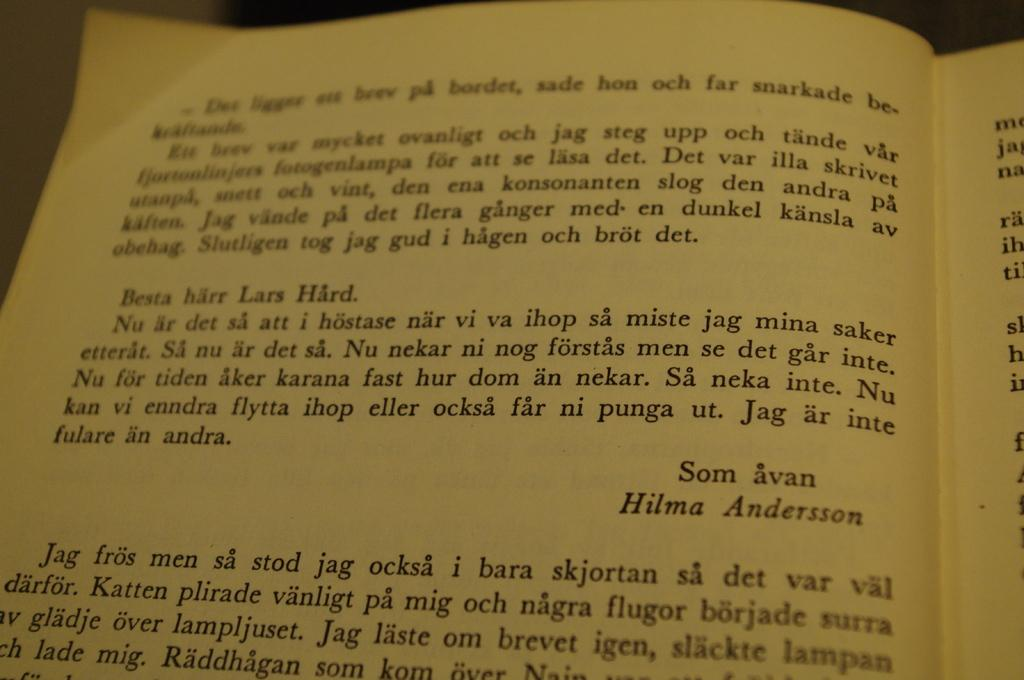<image>
Offer a succinct explanation of the picture presented. The current page includes a note to Lars Hard from Hilma Andersson. 